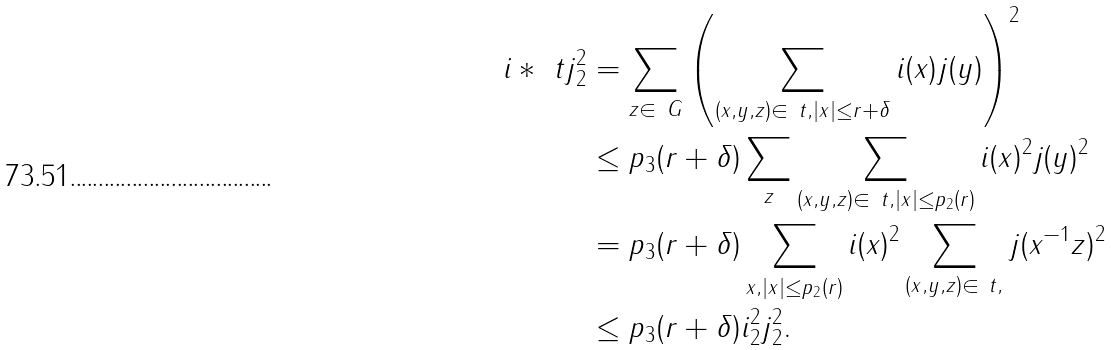Convert formula to latex. <formula><loc_0><loc_0><loc_500><loc_500>\| i * _ { \ } t j \| _ { 2 } ^ { 2 } & = \sum _ { z \in \ G } \left ( \sum _ { ( x , y , z ) \in \ t , | x | \leq r + \delta } i ( x ) j ( y ) \right ) ^ { 2 } \\ & \leq p _ { 3 } ( r + \delta ) \sum _ { z } \sum _ { ( x , y , z ) \in \ t , | x | \leq p _ { 2 } ( r ) } i ( x ) ^ { 2 } j ( y ) ^ { 2 } \\ & = p _ { 3 } ( r + \delta ) \sum _ { x , | x | \leq p _ { 2 } ( r ) } i ( x ) ^ { 2 } \sum _ { ( x , y , z ) \in \ t , } j ( x ^ { - 1 } z ) ^ { 2 } \\ & \leq p _ { 3 } ( r + \delta ) \| i \| _ { 2 } ^ { 2 } \| j \| _ { 2 } ^ { 2 } .</formula> 